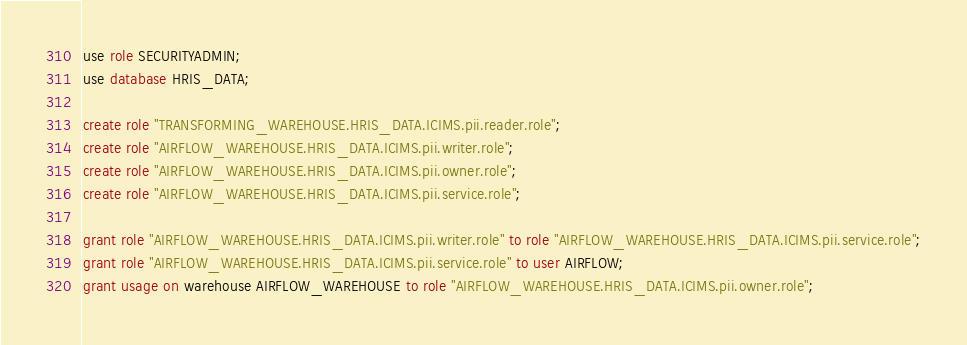Convert code to text. <code><loc_0><loc_0><loc_500><loc_500><_SQL_>
use role SECURITYADMIN;
use database HRIS_DATA;

create role "TRANSFORMING_WAREHOUSE.HRIS_DATA.ICIMS.pii.reader.role";
create role "AIRFLOW_WAREHOUSE.HRIS_DATA.ICIMS.pii.writer.role";
create role "AIRFLOW_WAREHOUSE.HRIS_DATA.ICIMS.pii.owner.role";
create role "AIRFLOW_WAREHOUSE.HRIS_DATA.ICIMS.pii.service.role";

grant role "AIRFLOW_WAREHOUSE.HRIS_DATA.ICIMS.pii.writer.role" to role "AIRFLOW_WAREHOUSE.HRIS_DATA.ICIMS.pii.service.role";
grant role "AIRFLOW_WAREHOUSE.HRIS_DATA.ICIMS.pii.service.role" to user AIRFLOW;
grant usage on warehouse AIRFLOW_WAREHOUSE to role "AIRFLOW_WAREHOUSE.HRIS_DATA.ICIMS.pii.owner.role";</code> 